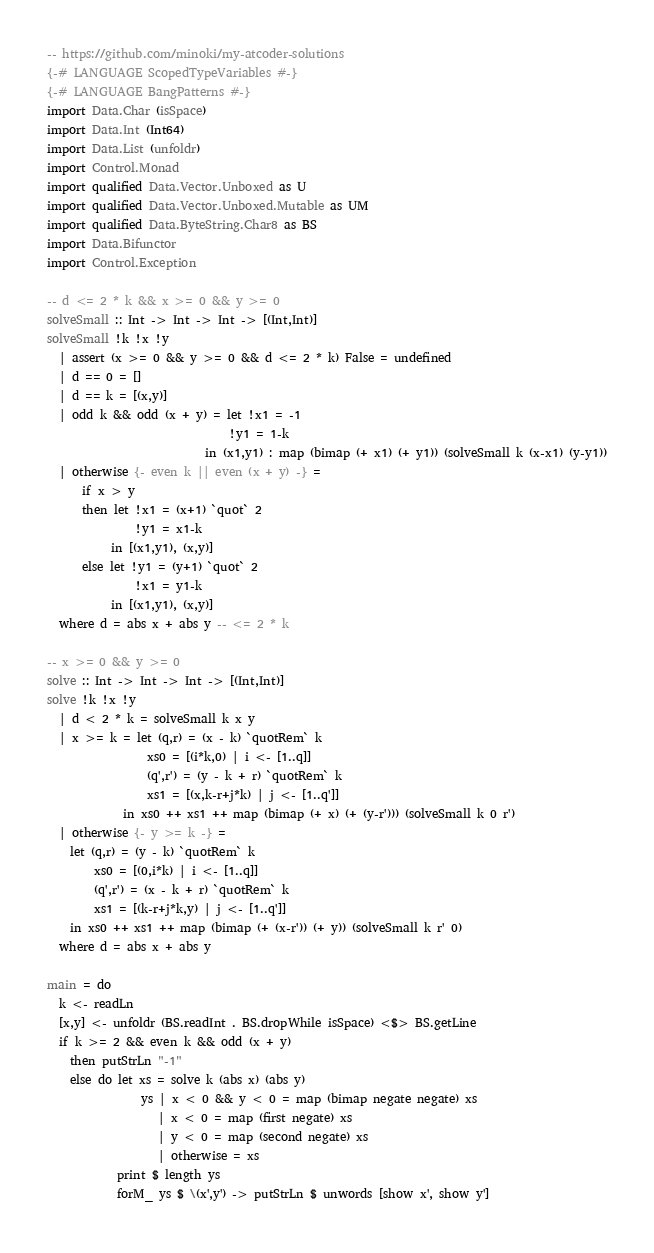Convert code to text. <code><loc_0><loc_0><loc_500><loc_500><_Haskell_>-- https://github.com/minoki/my-atcoder-solutions
{-# LANGUAGE ScopedTypeVariables #-}
{-# LANGUAGE BangPatterns #-}
import Data.Char (isSpace)
import Data.Int (Int64)
import Data.List (unfoldr)
import Control.Monad
import qualified Data.Vector.Unboxed as U
import qualified Data.Vector.Unboxed.Mutable as UM
import qualified Data.ByteString.Char8 as BS
import Data.Bifunctor
import Control.Exception

-- d <= 2 * k && x >= 0 && y >= 0
solveSmall :: Int -> Int -> Int -> [(Int,Int)]
solveSmall !k !x !y
  | assert (x >= 0 && y >= 0 && d <= 2 * k) False = undefined
  | d == 0 = []
  | d == k = [(x,y)]
  | odd k && odd (x + y) = let !x1 = -1
                               !y1 = 1-k
                           in (x1,y1) : map (bimap (+ x1) (+ y1)) (solveSmall k (x-x1) (y-y1))
  | otherwise {- even k || even (x + y) -} =
      if x > y
      then let !x1 = (x+1) `quot` 2
               !y1 = x1-k
           in [(x1,y1), (x,y)]
      else let !y1 = (y+1) `quot` 2
               !x1 = y1-k
           in [(x1,y1), (x,y)]
  where d = abs x + abs y -- <= 2 * k

-- x >= 0 && y >= 0
solve :: Int -> Int -> Int -> [(Int,Int)]
solve !k !x !y
  | d < 2 * k = solveSmall k x y
  | x >= k = let (q,r) = (x - k) `quotRem` k
                 xs0 = [(i*k,0) | i <- [1..q]]
                 (q',r') = (y - k + r) `quotRem` k
                 xs1 = [(x,k-r+j*k) | j <- [1..q']]
             in xs0 ++ xs1 ++ map (bimap (+ x) (+ (y-r'))) (solveSmall k 0 r')
  | otherwise {- y >= k -} =
    let (q,r) = (y - k) `quotRem` k
        xs0 = [(0,i*k) | i <- [1..q]]
        (q',r') = (x - k + r) `quotRem` k
        xs1 = [(k-r+j*k,y) | j <- [1..q']]
    in xs0 ++ xs1 ++ map (bimap (+ (x-r')) (+ y)) (solveSmall k r' 0)
  where d = abs x + abs y

main = do
  k <- readLn
  [x,y] <- unfoldr (BS.readInt . BS.dropWhile isSpace) <$> BS.getLine
  if k >= 2 && even k && odd (x + y)
    then putStrLn "-1"
    else do let xs = solve k (abs x) (abs y)
                ys | x < 0 && y < 0 = map (bimap negate negate) xs
                   | x < 0 = map (first negate) xs
                   | y < 0 = map (second negate) xs
                   | otherwise = xs
            print $ length ys
            forM_ ys $ \(x',y') -> putStrLn $ unwords [show x', show y']
</code> 